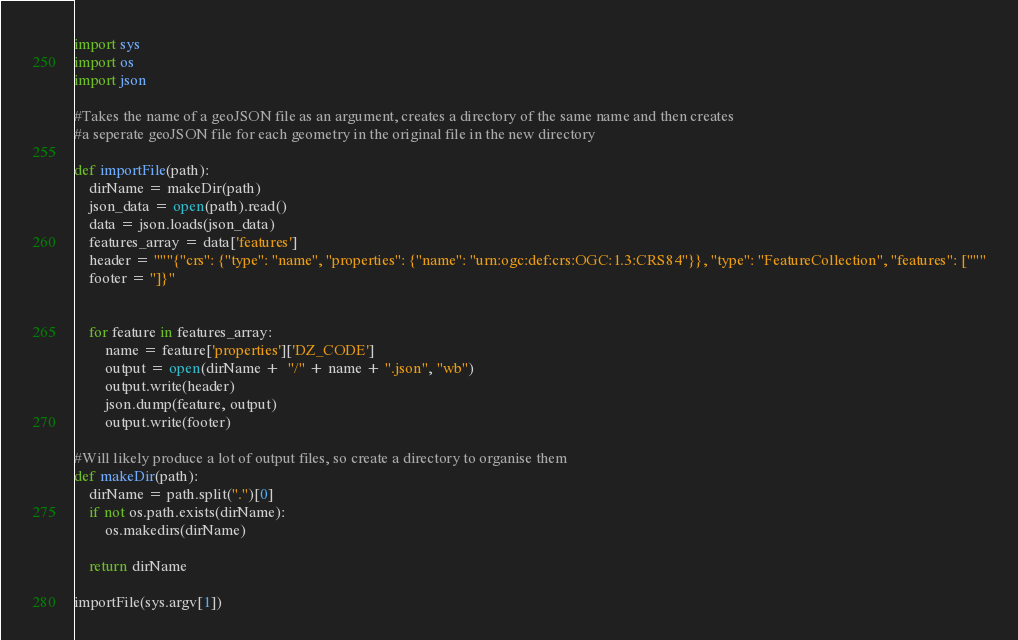Convert code to text. <code><loc_0><loc_0><loc_500><loc_500><_Python_>import sys
import os
import json

#Takes the name of a geoJSON file as an argument, creates a directory of the same name and then creates
#a seperate geoJSON file for each geometry in the original file in the new directory

def importFile(path):
    dirName = makeDir(path)
    json_data = open(path).read()
    data = json.loads(json_data)
    features_array = data['features']
    header = """{"crs": {"type": "name", "properties": {"name": "urn:ogc:def:crs:OGC:1.3:CRS84"}}, "type": "FeatureCollection", "features": ["""
    footer = "]}"


    for feature in features_array:
        name = feature['properties']['DZ_CODE']
        output = open(dirName +  "/" + name + ".json", "wb")
        output.write(header)
        json.dump(feature, output)
        output.write(footer)

#Will likely produce a lot of output files, so create a directory to organise them
def makeDir(path):
    dirName = path.split(".")[0]
    if not os.path.exists(dirName):
        os.makedirs(dirName)

    return dirName

importFile(sys.argv[1])</code> 